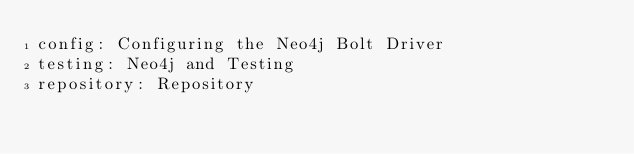Convert code to text. <code><loc_0><loc_0><loc_500><loc_500><_YAML_>config: Configuring the Neo4j Bolt Driver
testing: Neo4j and Testing
repository: Repository</code> 